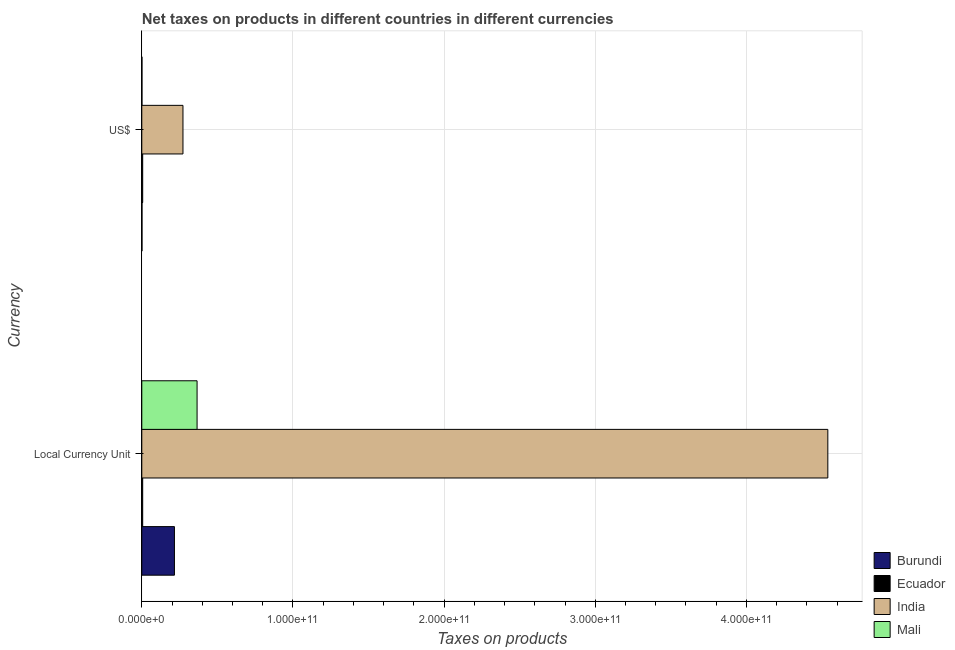Are the number of bars on each tick of the Y-axis equal?
Offer a very short reply. Yes. How many bars are there on the 1st tick from the top?
Your answer should be very brief. 4. What is the label of the 1st group of bars from the top?
Your response must be concise. US$. What is the net taxes in us$ in Ecuador?
Keep it short and to the point. 5.91e+08. Across all countries, what is the maximum net taxes in constant 2005 us$?
Provide a succinct answer. 4.54e+11. Across all countries, what is the minimum net taxes in constant 2005 us$?
Your answer should be very brief. 5.91e+08. In which country was the net taxes in constant 2005 us$ minimum?
Ensure brevity in your answer.  Ecuador. What is the total net taxes in us$ in the graph?
Offer a terse response. 2.81e+1. What is the difference between the net taxes in us$ in Mali and that in India?
Ensure brevity in your answer.  -2.71e+1. What is the difference between the net taxes in constant 2005 us$ in Ecuador and the net taxes in us$ in Mali?
Make the answer very short. 4.76e+08. What is the average net taxes in us$ per country?
Keep it short and to the point. 7.02e+09. What is the difference between the net taxes in us$ and net taxes in constant 2005 us$ in Mali?
Offer a very short reply. -3.65e+1. What is the ratio of the net taxes in constant 2005 us$ in Ecuador to that in Burundi?
Make the answer very short. 0.03. In how many countries, is the net taxes in us$ greater than the average net taxes in us$ taken over all countries?
Your response must be concise. 1. What does the 1st bar from the top in US$ represents?
Provide a short and direct response. Mali. What does the 3rd bar from the bottom in Local Currency Unit represents?
Provide a succinct answer. India. How many bars are there?
Offer a terse response. 8. How many countries are there in the graph?
Your answer should be compact. 4. What is the difference between two consecutive major ticks on the X-axis?
Offer a very short reply. 1.00e+11. Does the graph contain any zero values?
Your answer should be very brief. No. Does the graph contain grids?
Ensure brevity in your answer.  Yes. What is the title of the graph?
Your answer should be compact. Net taxes on products in different countries in different currencies. What is the label or title of the X-axis?
Make the answer very short. Taxes on products. What is the label or title of the Y-axis?
Your response must be concise. Currency. What is the Taxes on products in Burundi in Local Currency Unit?
Your answer should be compact. 2.16e+1. What is the Taxes on products in Ecuador in Local Currency Unit?
Ensure brevity in your answer.  5.91e+08. What is the Taxes on products in India in Local Currency Unit?
Give a very brief answer. 4.54e+11. What is the Taxes on products in Mali in Local Currency Unit?
Offer a terse response. 3.66e+1. What is the Taxes on products of Burundi in US$?
Ensure brevity in your answer.  1.36e+08. What is the Taxes on products in Ecuador in US$?
Provide a succinct answer. 5.91e+08. What is the Taxes on products in India in US$?
Your answer should be very brief. 2.72e+1. What is the Taxes on products of Mali in US$?
Your answer should be compact. 1.15e+08. Across all Currency, what is the maximum Taxes on products in Burundi?
Provide a succinct answer. 2.16e+1. Across all Currency, what is the maximum Taxes on products in Ecuador?
Make the answer very short. 5.91e+08. Across all Currency, what is the maximum Taxes on products in India?
Offer a terse response. 4.54e+11. Across all Currency, what is the maximum Taxes on products in Mali?
Provide a succinct answer. 3.66e+1. Across all Currency, what is the minimum Taxes on products of Burundi?
Keep it short and to the point. 1.36e+08. Across all Currency, what is the minimum Taxes on products in Ecuador?
Offer a terse response. 5.91e+08. Across all Currency, what is the minimum Taxes on products of India?
Offer a very short reply. 2.72e+1. Across all Currency, what is the minimum Taxes on products of Mali?
Offer a terse response. 1.15e+08. What is the total Taxes on products of Burundi in the graph?
Ensure brevity in your answer.  2.17e+1. What is the total Taxes on products in Ecuador in the graph?
Offer a very short reply. 1.18e+09. What is the total Taxes on products in India in the graph?
Keep it short and to the point. 4.81e+11. What is the total Taxes on products of Mali in the graph?
Offer a terse response. 3.67e+1. What is the difference between the Taxes on products of Burundi in Local Currency Unit and that in US$?
Ensure brevity in your answer.  2.15e+1. What is the difference between the Taxes on products in Ecuador in Local Currency Unit and that in US$?
Make the answer very short. -2.83e+05. What is the difference between the Taxes on products in India in Local Currency Unit and that in US$?
Give a very brief answer. 4.27e+11. What is the difference between the Taxes on products of Mali in Local Currency Unit and that in US$?
Ensure brevity in your answer.  3.65e+1. What is the difference between the Taxes on products in Burundi in Local Currency Unit and the Taxes on products in Ecuador in US$?
Keep it short and to the point. 2.10e+1. What is the difference between the Taxes on products of Burundi in Local Currency Unit and the Taxes on products of India in US$?
Your answer should be very brief. -5.65e+09. What is the difference between the Taxes on products of Burundi in Local Currency Unit and the Taxes on products of Mali in US$?
Provide a succinct answer. 2.15e+1. What is the difference between the Taxes on products of Ecuador in Local Currency Unit and the Taxes on products of India in US$?
Make the answer very short. -2.66e+1. What is the difference between the Taxes on products of Ecuador in Local Currency Unit and the Taxes on products of Mali in US$?
Your response must be concise. 4.76e+08. What is the difference between the Taxes on products in India in Local Currency Unit and the Taxes on products in Mali in US$?
Your response must be concise. 4.54e+11. What is the average Taxes on products of Burundi per Currency?
Your response must be concise. 1.09e+1. What is the average Taxes on products in Ecuador per Currency?
Offer a very short reply. 5.91e+08. What is the average Taxes on products of India per Currency?
Give a very brief answer. 2.41e+11. What is the average Taxes on products of Mali per Currency?
Offer a very short reply. 1.83e+1. What is the difference between the Taxes on products in Burundi and Taxes on products in Ecuador in Local Currency Unit?
Your answer should be compact. 2.10e+1. What is the difference between the Taxes on products in Burundi and Taxes on products in India in Local Currency Unit?
Your answer should be very brief. -4.32e+11. What is the difference between the Taxes on products of Burundi and Taxes on products of Mali in Local Currency Unit?
Ensure brevity in your answer.  -1.50e+1. What is the difference between the Taxes on products in Ecuador and Taxes on products in India in Local Currency Unit?
Your response must be concise. -4.53e+11. What is the difference between the Taxes on products in Ecuador and Taxes on products in Mali in Local Currency Unit?
Provide a short and direct response. -3.60e+1. What is the difference between the Taxes on products of India and Taxes on products of Mali in Local Currency Unit?
Your answer should be very brief. 4.17e+11. What is the difference between the Taxes on products in Burundi and Taxes on products in Ecuador in US$?
Ensure brevity in your answer.  -4.55e+08. What is the difference between the Taxes on products of Burundi and Taxes on products of India in US$?
Your answer should be very brief. -2.71e+1. What is the difference between the Taxes on products of Burundi and Taxes on products of Mali in US$?
Provide a succinct answer. 2.14e+07. What is the difference between the Taxes on products of Ecuador and Taxes on products of India in US$?
Ensure brevity in your answer.  -2.66e+1. What is the difference between the Taxes on products in Ecuador and Taxes on products in Mali in US$?
Keep it short and to the point. 4.76e+08. What is the difference between the Taxes on products of India and Taxes on products of Mali in US$?
Your response must be concise. 2.71e+1. What is the ratio of the Taxes on products of Burundi in Local Currency Unit to that in US$?
Offer a terse response. 158.67. What is the ratio of the Taxes on products in India in Local Currency Unit to that in US$?
Ensure brevity in your answer.  16.66. What is the ratio of the Taxes on products of Mali in Local Currency Unit to that in US$?
Provide a succinct answer. 319.01. What is the difference between the highest and the second highest Taxes on products of Burundi?
Your answer should be very brief. 2.15e+1. What is the difference between the highest and the second highest Taxes on products in Ecuador?
Your answer should be very brief. 2.83e+05. What is the difference between the highest and the second highest Taxes on products of India?
Your answer should be compact. 4.27e+11. What is the difference between the highest and the second highest Taxes on products of Mali?
Offer a very short reply. 3.65e+1. What is the difference between the highest and the lowest Taxes on products of Burundi?
Offer a very short reply. 2.15e+1. What is the difference between the highest and the lowest Taxes on products in Ecuador?
Your answer should be very brief. 2.83e+05. What is the difference between the highest and the lowest Taxes on products in India?
Give a very brief answer. 4.27e+11. What is the difference between the highest and the lowest Taxes on products in Mali?
Ensure brevity in your answer.  3.65e+1. 